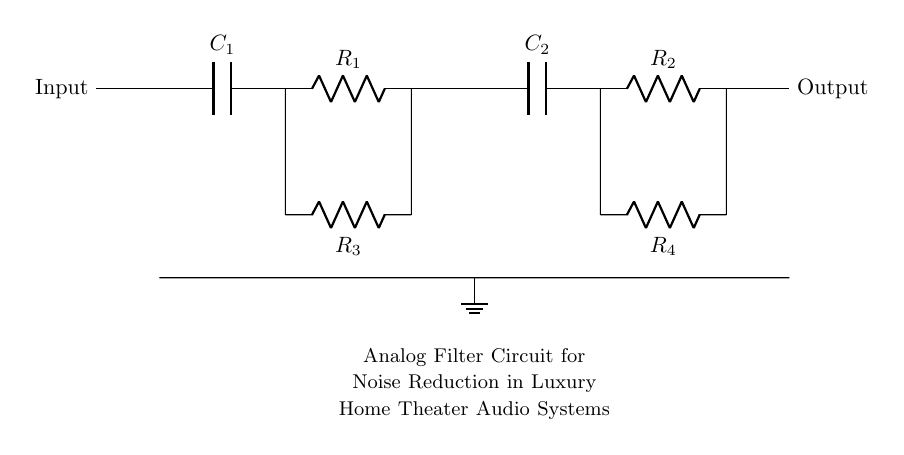What type of circuit is shown? The circuit is an analog filter circuit designed specifically for audio systems, indicated by the combination of capacitors and resistors aimed at noise reduction.
Answer: analog filter circuit How many resistors are present in the circuit? The circuit contains four resistors: R1, R2, R3, and R4, which are all clearly labeled in the diagram.
Answer: four What is the purpose of capacitor C1? Capacitor C1 is typically used in filtering applications to block DC while allowing AC signals to pass, contributing to noise reduction in the audio signal.
Answer: noise reduction What is the relationship between R3 and R1? R3 is in parallel with R1, meaning that they share the same voltage across their terminals while their currents can vary independently, impacting the overall impedance of the circuit.
Answer: parallel What is the overall function of this circuit? The overall function is to reduce noise in audio systems used in luxury home theaters, allowing clearer sound by attenuating unwanted frequencies.
Answer: noise reduction Which components are used to ground the circuit? The circuit is grounded by a node connected to a ground symbol, specifically at the point beneath capacitors C1 and C2, ensuring a reference point for the circuit's operation.
Answer: ground symbol What would happen if C2 were removed from the circuit? Removing C2 would likely result in a higher cutoff frequency for the filter, allowing more high-frequency noise to pass through and negatively affecting audio quality in the system.
Answer: increased high-frequency noise 